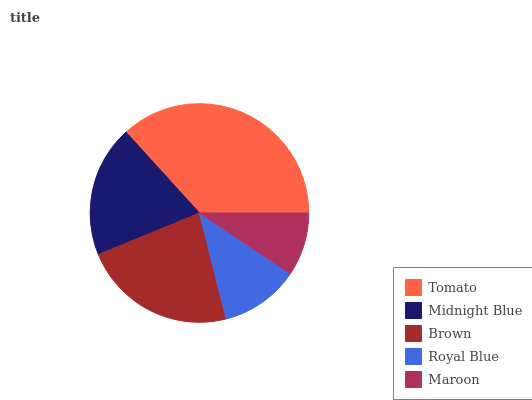Is Maroon the minimum?
Answer yes or no. Yes. Is Tomato the maximum?
Answer yes or no. Yes. Is Midnight Blue the minimum?
Answer yes or no. No. Is Midnight Blue the maximum?
Answer yes or no. No. Is Tomato greater than Midnight Blue?
Answer yes or no. Yes. Is Midnight Blue less than Tomato?
Answer yes or no. Yes. Is Midnight Blue greater than Tomato?
Answer yes or no. No. Is Tomato less than Midnight Blue?
Answer yes or no. No. Is Midnight Blue the high median?
Answer yes or no. Yes. Is Midnight Blue the low median?
Answer yes or no. Yes. Is Tomato the high median?
Answer yes or no. No. Is Maroon the low median?
Answer yes or no. No. 